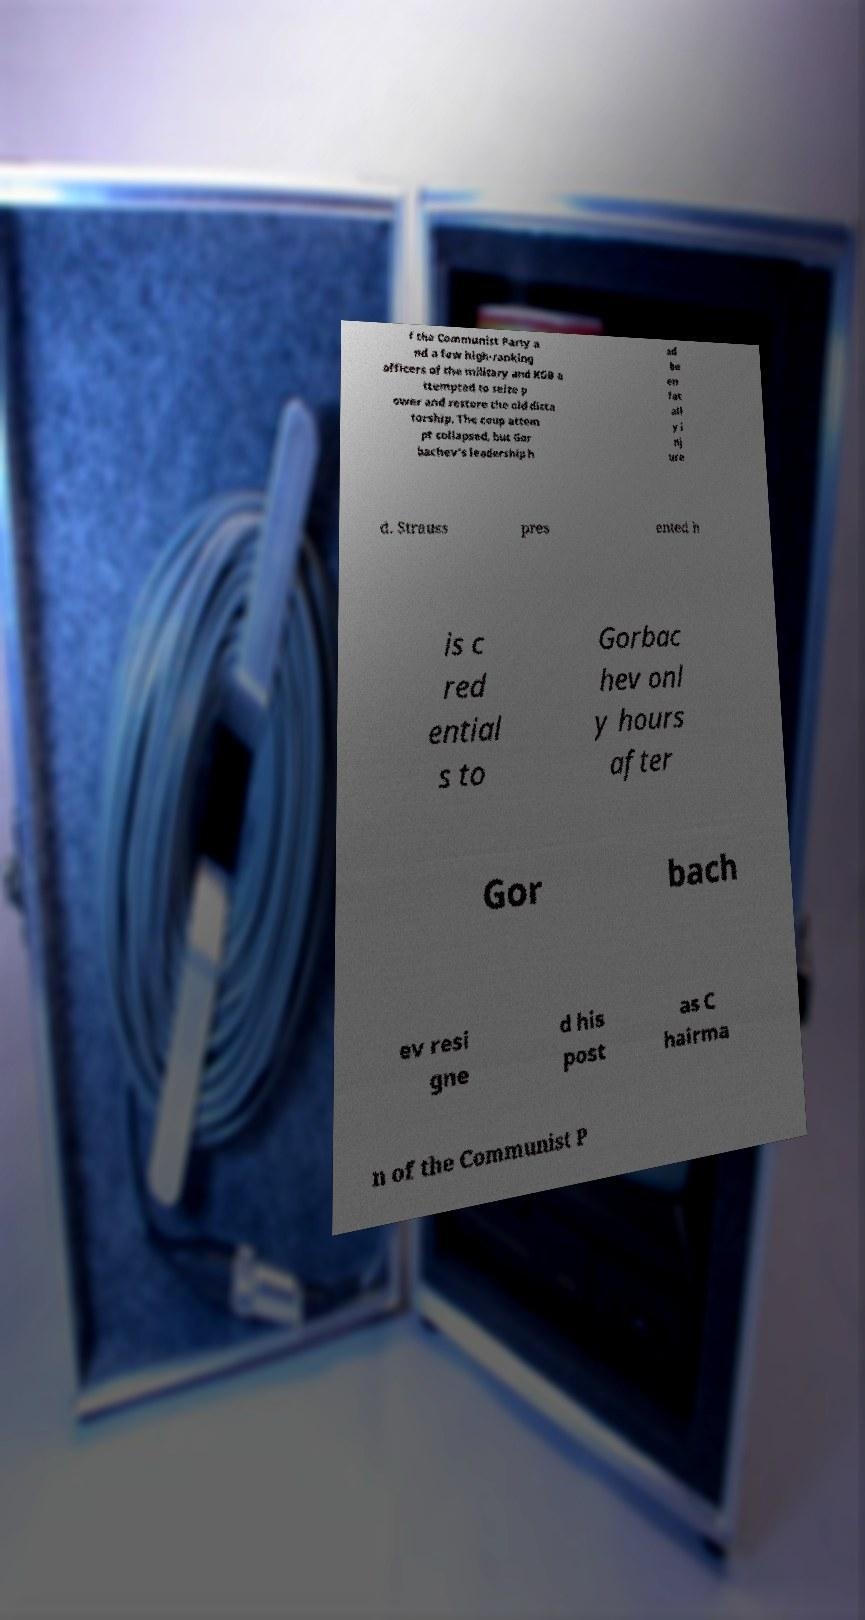Please read and relay the text visible in this image. What does it say? f the Communist Party a nd a few high-ranking officers of the military and KGB a ttempted to seize p ower and restore the old dicta torship. The coup attem pt collapsed, but Gor bachev's leadership h ad be en fat all y i nj ure d. Strauss pres ented h is c red ential s to Gorbac hev onl y hours after Gor bach ev resi gne d his post as C hairma n of the Communist P 